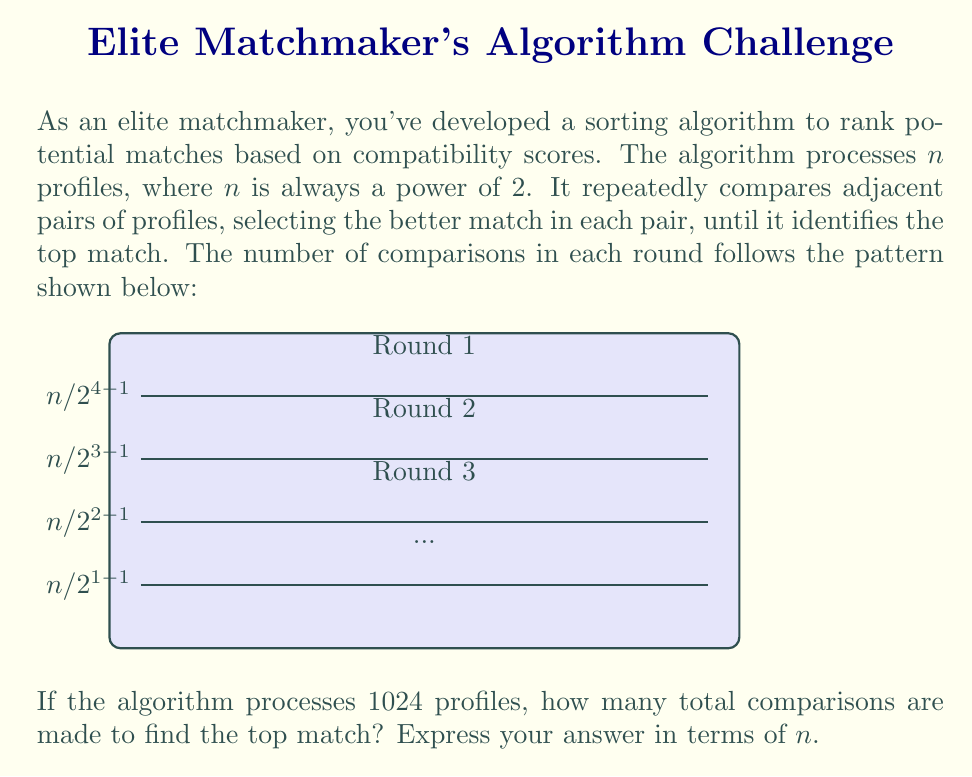Solve this math problem. Let's approach this step-by-step:

1) First, we need to identify the number of rounds. Since $n$ is always a power of 2, the number of rounds will be $\log_2(n)$. In this case, $\log_2(1024) = 10$ rounds.

2) Now, let's look at the number of comparisons in each round:
   - Round 1: $n/2$ comparisons
   - Round 2: $n/4$ comparisons
   - Round 3: $n/8$ comparisons
   ...and so on.

3) We can express this as a sum:

   $$\frac{n}{2} + \frac{n}{4} + \frac{n}{8} + ... + 1$$

4) This is a geometric series with $\log_2(n)$ terms, first term $a = n/2$, and common ratio $r = 1/2$.

5) The sum of a geometric series is given by the formula:
   
   $$S = \frac{a(1-r^k)}{1-r}$$

   where $k$ is the number of terms.

6) In our case:
   $a = n/2$
   $r = 1/2$
   $k = \log_2(n)$

7) Substituting these values:

   $$S = \frac{\frac{n}{2}(1-(\frac{1}{2})^{\log_2(n)})}{1-\frac{1}{2}}$$

8) Simplify:
   $$S = n(1-\frac{1}{n}) = n - 1$$

Therefore, the total number of comparisons is $n - 1$.
Answer: $n - 1$ 